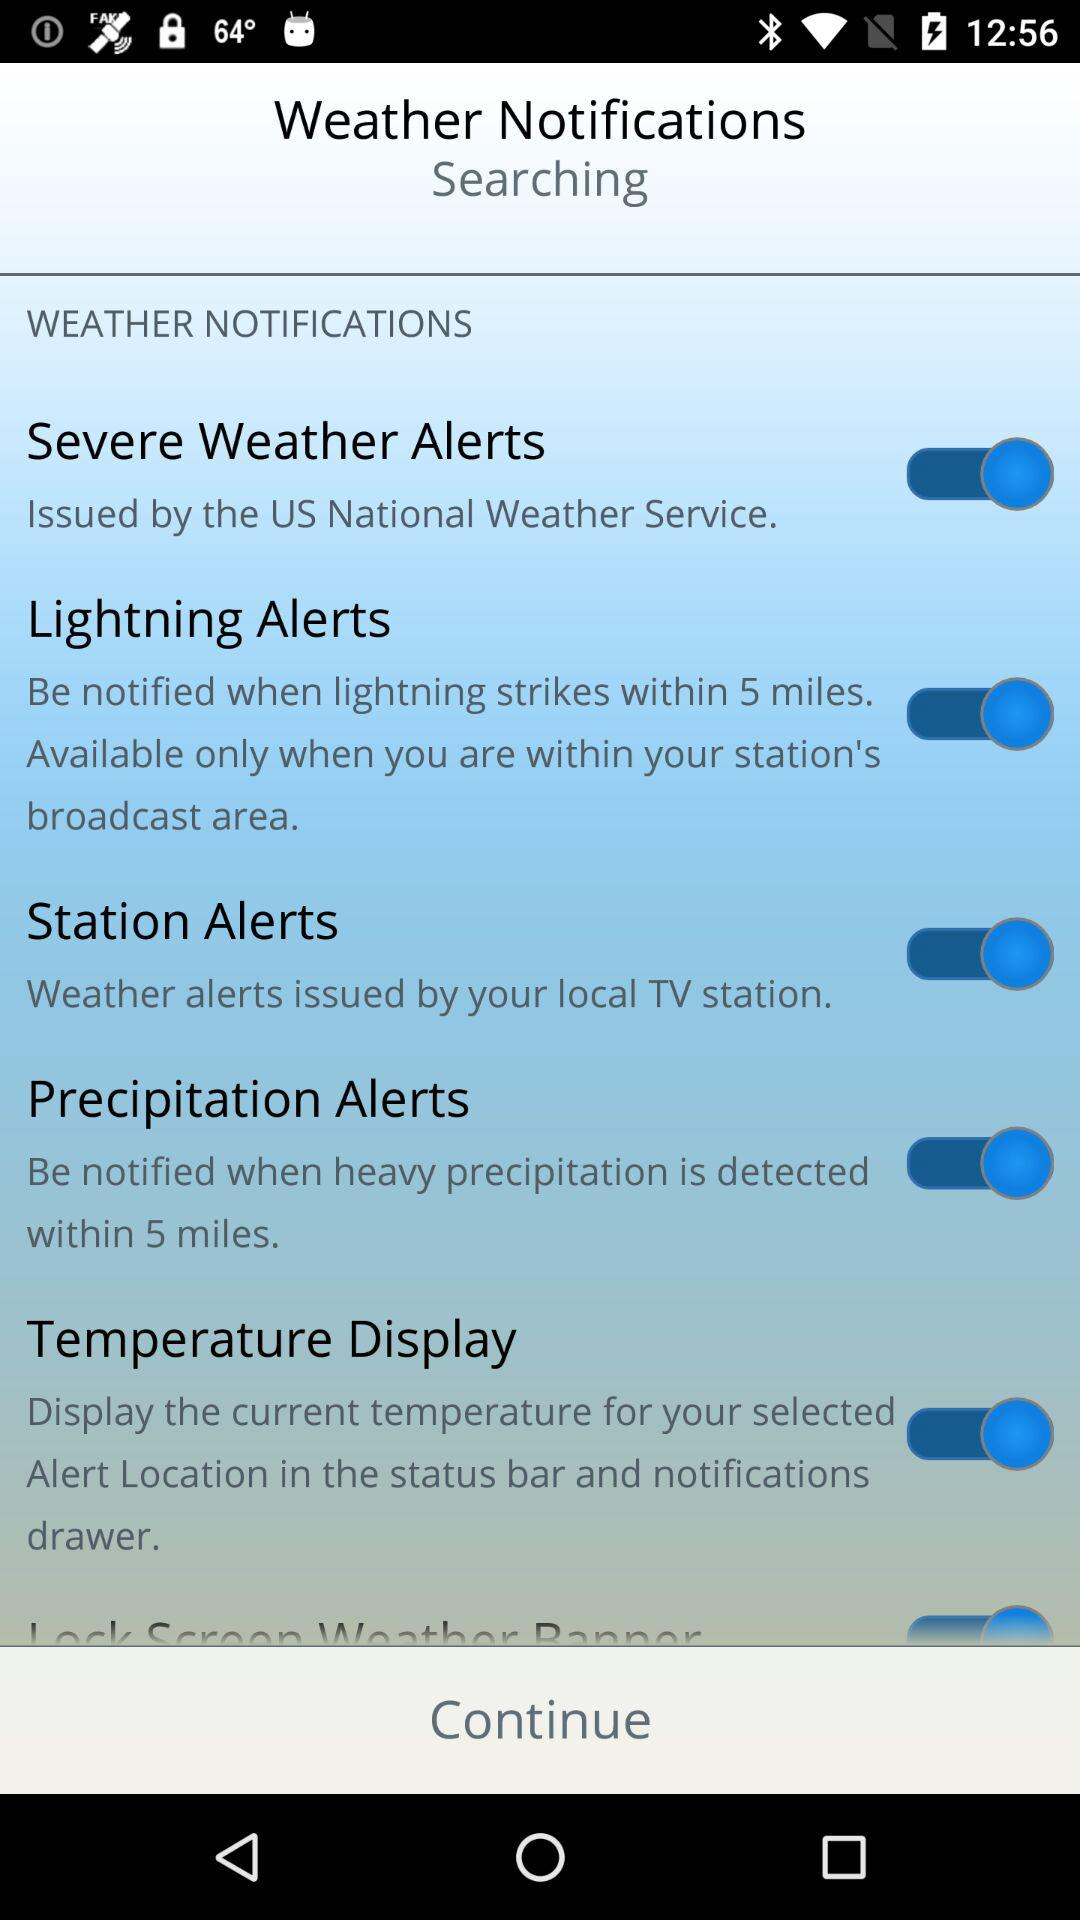Where is the temperature displayed? The temperature is displayed in the status bar and notifications drawer. 